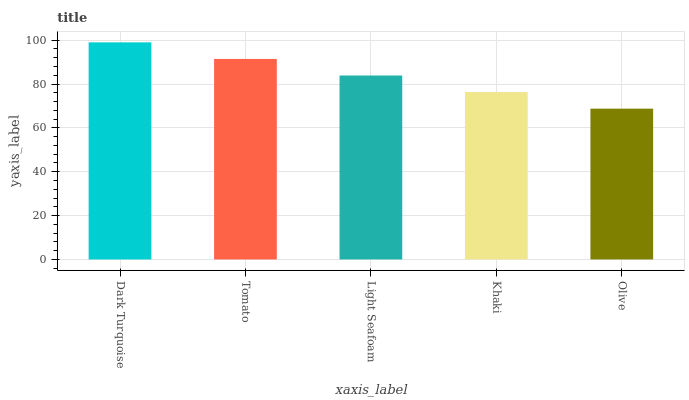Is Tomato the minimum?
Answer yes or no. No. Is Tomato the maximum?
Answer yes or no. No. Is Dark Turquoise greater than Tomato?
Answer yes or no. Yes. Is Tomato less than Dark Turquoise?
Answer yes or no. Yes. Is Tomato greater than Dark Turquoise?
Answer yes or no. No. Is Dark Turquoise less than Tomato?
Answer yes or no. No. Is Light Seafoam the high median?
Answer yes or no. Yes. Is Light Seafoam the low median?
Answer yes or no. Yes. Is Olive the high median?
Answer yes or no. No. Is Dark Turquoise the low median?
Answer yes or no. No. 